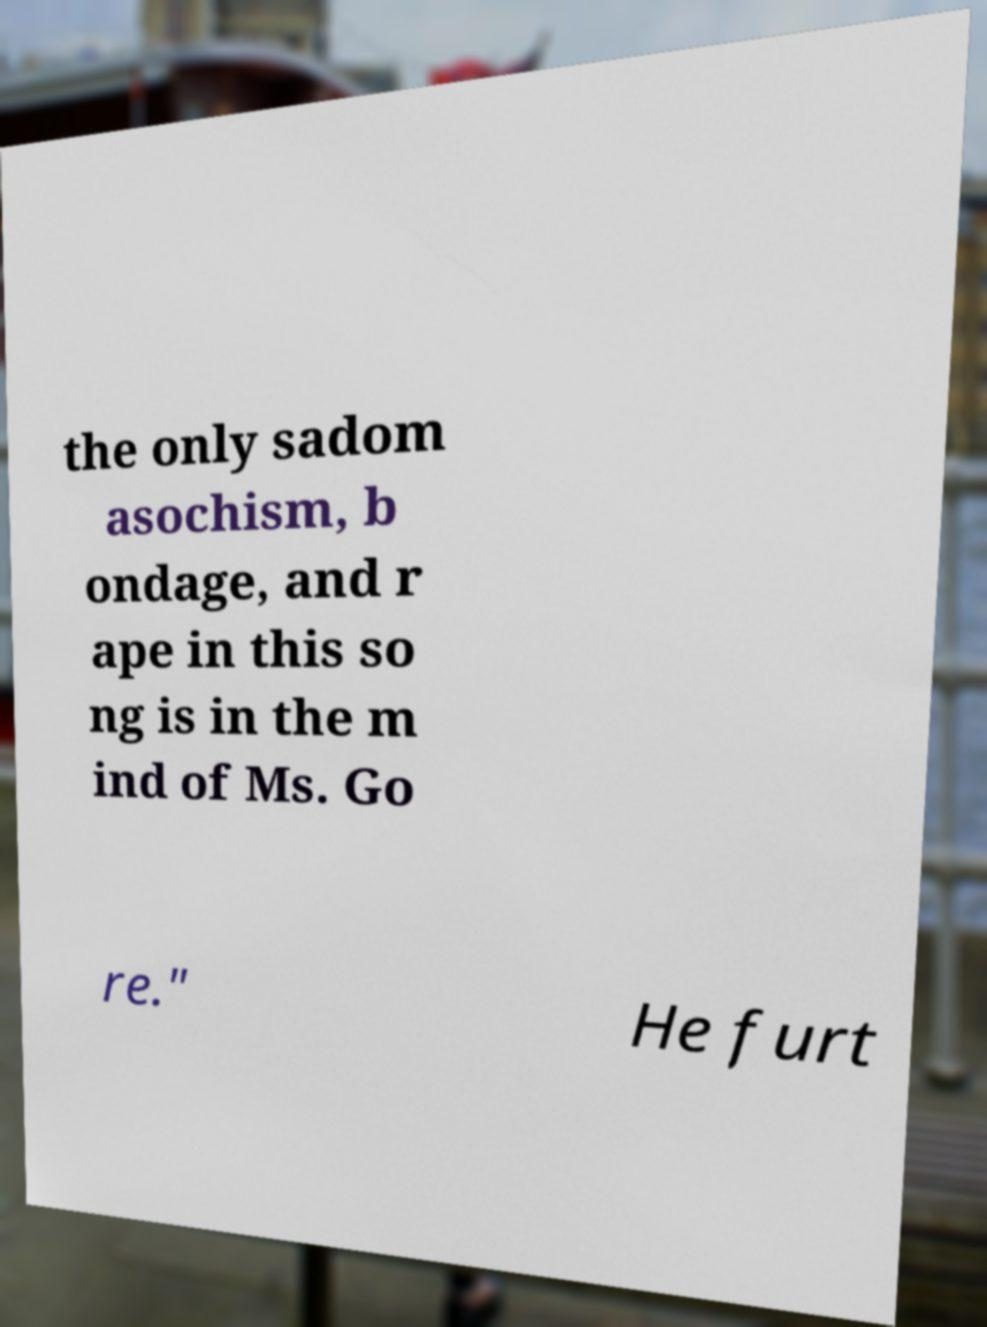Could you extract and type out the text from this image? the only sadom asochism, b ondage, and r ape in this so ng is in the m ind of Ms. Go re." He furt 